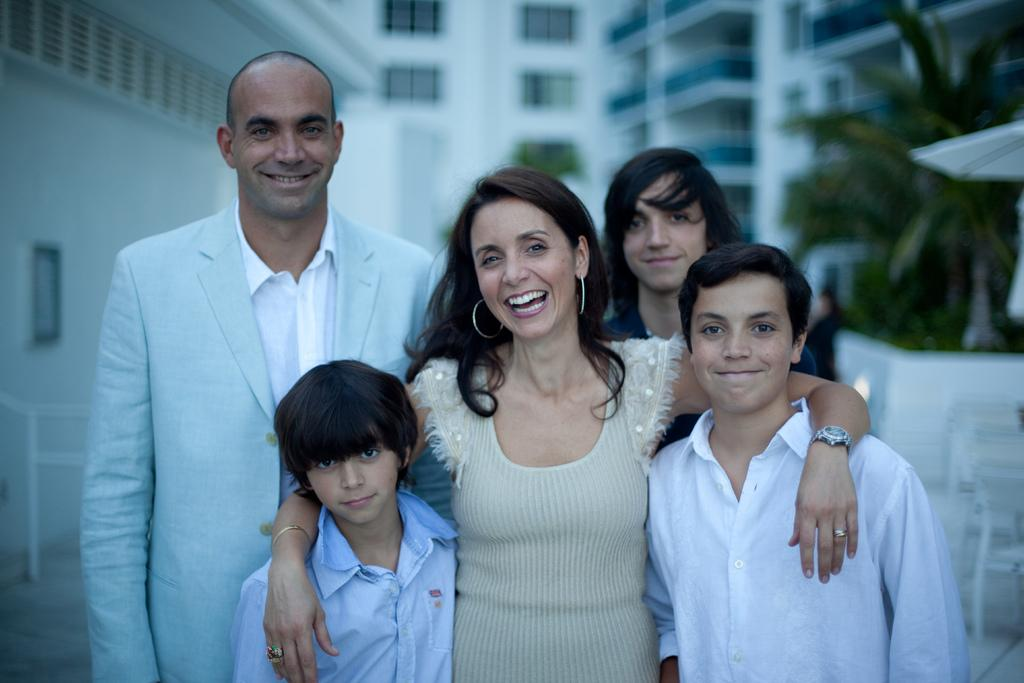What can be seen at the bottom of the image? There is a group of persons standing at the bottom of the image. What is visible in the background of the image? There are buildings in the background of the image. What type of vegetation is on the right side of the image? There is a tree on the right side of the image. What type of flag is visible on the tree in the image? There is no flag present on the tree in the image. What is the range of the bomb that can be seen in the image? There is no bomb present in the image. 